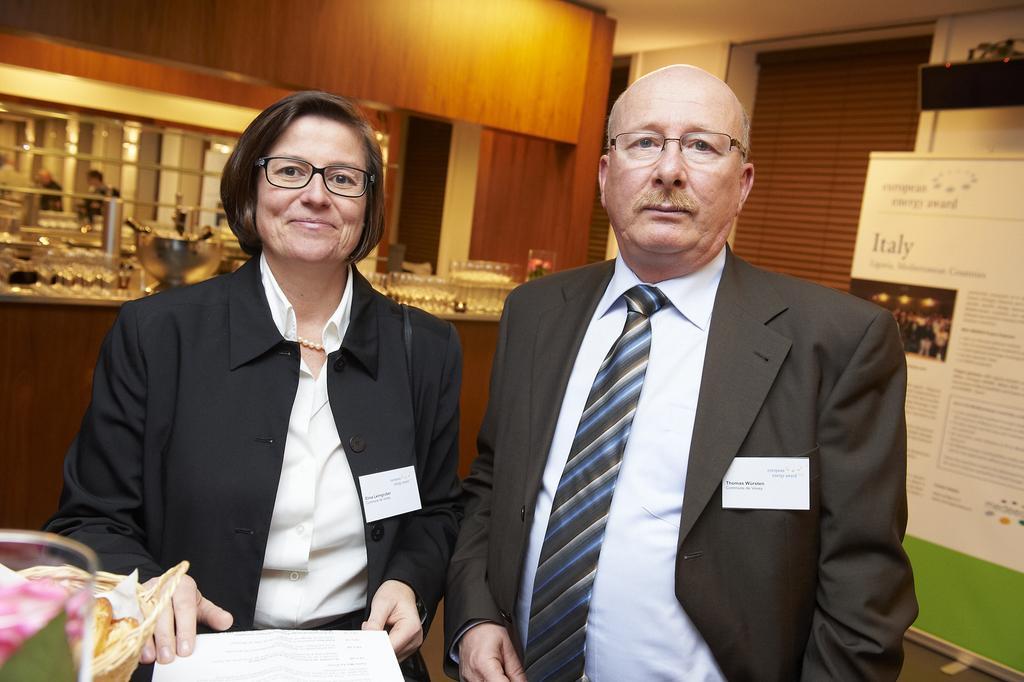Can you describe this image briefly? In this image there is a man with glasses and a woman holding a paper and wearing glasses and smiling. In the background we can see many glasses and also steel container on the wooden surface. On the right there is a poster to the wall. 